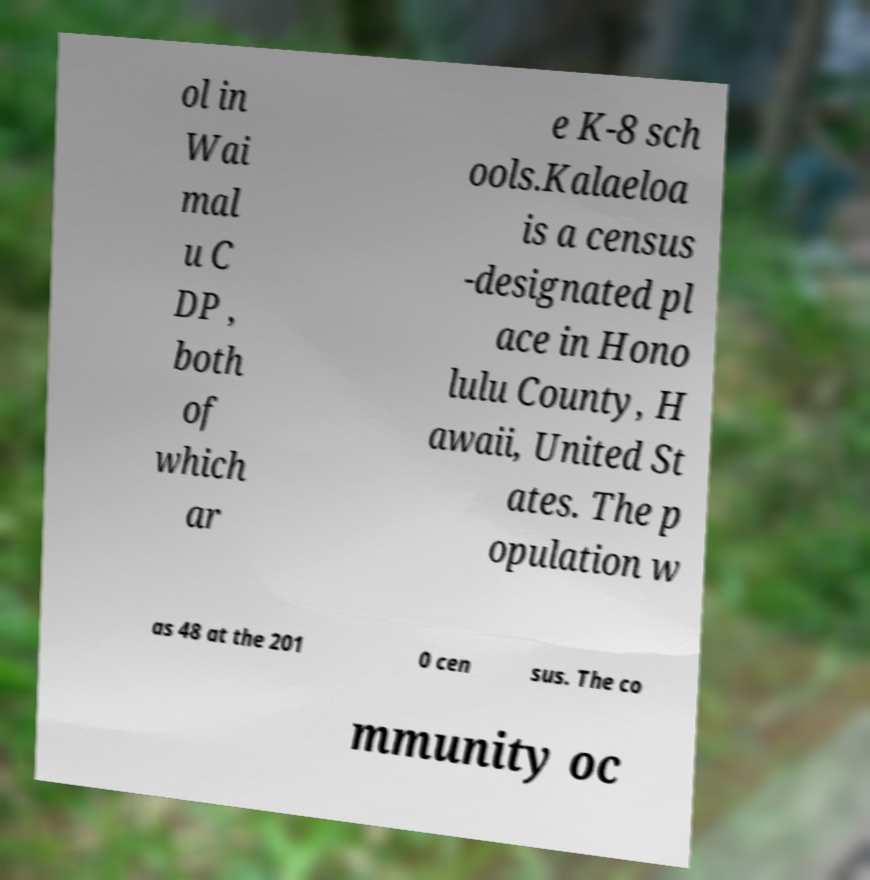Please read and relay the text visible in this image. What does it say? ol in Wai mal u C DP , both of which ar e K-8 sch ools.Kalaeloa is a census -designated pl ace in Hono lulu County, H awaii, United St ates. The p opulation w as 48 at the 201 0 cen sus. The co mmunity oc 